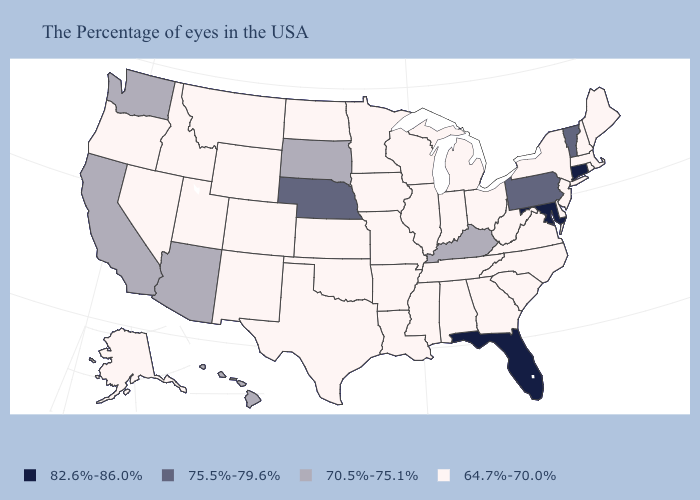Among the states that border Illinois , does Kentucky have the highest value?
Write a very short answer. Yes. Does Alaska have the highest value in the USA?
Short answer required. No. Among the states that border Oklahoma , which have the lowest value?
Quick response, please. Missouri, Arkansas, Kansas, Texas, Colorado, New Mexico. What is the value of Virginia?
Answer briefly. 64.7%-70.0%. Name the states that have a value in the range 82.6%-86.0%?
Keep it brief. Connecticut, Maryland, Florida. What is the value of Washington?
Short answer required. 70.5%-75.1%. How many symbols are there in the legend?
Short answer required. 4. What is the value of South Dakota?
Answer briefly. 70.5%-75.1%. What is the value of New Jersey?
Give a very brief answer. 64.7%-70.0%. Name the states that have a value in the range 64.7%-70.0%?
Quick response, please. Maine, Massachusetts, Rhode Island, New Hampshire, New York, New Jersey, Delaware, Virginia, North Carolina, South Carolina, West Virginia, Ohio, Georgia, Michigan, Indiana, Alabama, Tennessee, Wisconsin, Illinois, Mississippi, Louisiana, Missouri, Arkansas, Minnesota, Iowa, Kansas, Oklahoma, Texas, North Dakota, Wyoming, Colorado, New Mexico, Utah, Montana, Idaho, Nevada, Oregon, Alaska. Does Missouri have the lowest value in the USA?
Keep it brief. Yes. Which states hav the highest value in the South?
Short answer required. Maryland, Florida. What is the value of North Carolina?
Answer briefly. 64.7%-70.0%. What is the value of Rhode Island?
Keep it brief. 64.7%-70.0%. Among the states that border Minnesota , which have the lowest value?
Give a very brief answer. Wisconsin, Iowa, North Dakota. 